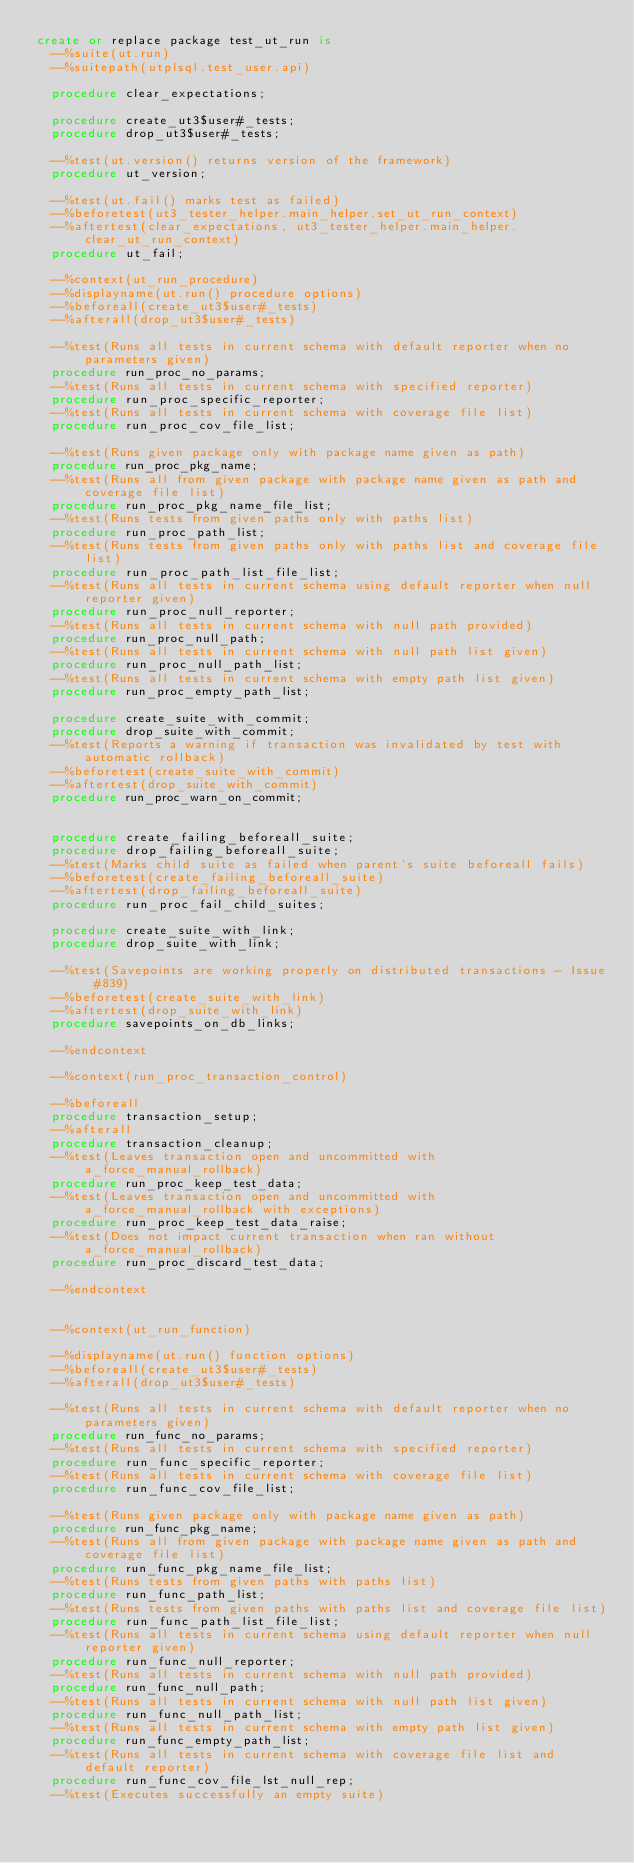Convert code to text. <code><loc_0><loc_0><loc_500><loc_500><_SQL_>create or replace package test_ut_run is
  --%suite(ut.run)
  --%suitepath(utplsql.test_user.api)

  procedure clear_expectations;
  
  procedure create_ut3$user#_tests;
  procedure drop_ut3$user#_tests;  
  
  --%test(ut.version() returns version of the framework)
  procedure ut_version;

  --%test(ut.fail() marks test as failed)
  --%beforetest(ut3_tester_helper.main_helper.set_ut_run_context)
  --%aftertest(clear_expectations, ut3_tester_helper.main_helper.clear_ut_run_context)
  procedure ut_fail;

  --%context(ut_run_procedure)
  --%displayname(ut.run() procedure options)
  --%beforeall(create_ut3$user#_tests)
  --%afterall(drop_ut3$user#_tests)

  --%test(Runs all tests in current schema with default reporter when no parameters given)
  procedure run_proc_no_params;
  --%test(Runs all tests in current schema with specified reporter)
  procedure run_proc_specific_reporter;
  --%test(Runs all tests in current schema with coverage file list)
  procedure run_proc_cov_file_list;

  --%test(Runs given package only with package name given as path)
  procedure run_proc_pkg_name;
  --%test(Runs all from given package with package name given as path and coverage file list)
  procedure run_proc_pkg_name_file_list;
  --%test(Runs tests from given paths only with paths list)
  procedure run_proc_path_list;
  --%test(Runs tests from given paths only with paths list and coverage file list)
  procedure run_proc_path_list_file_list;
  --%test(Runs all tests in current schema using default reporter when null reporter given)
  procedure run_proc_null_reporter;
  --%test(Runs all tests in current schema with null path provided)
  procedure run_proc_null_path;
  --%test(Runs all tests in current schema with null path list given)
  procedure run_proc_null_path_list;
  --%test(Runs all tests in current schema with empty path list given)
  procedure run_proc_empty_path_list;

  procedure create_suite_with_commit;
  procedure drop_suite_with_commit;
  --%test(Reports a warning if transaction was invalidated by test with automatic rollback)
  --%beforetest(create_suite_with_commit)
  --%aftertest(drop_suite_with_commit)
  procedure run_proc_warn_on_commit;


  procedure create_failing_beforeall_suite;
  procedure drop_failing_beforeall_suite;
  --%test(Marks child suite as failed when parent's suite beforeall fails)
  --%beforetest(create_failing_beforeall_suite)
  --%aftertest(drop_failing_beforeall_suite)
  procedure run_proc_fail_child_suites;

  procedure create_suite_with_link;
  procedure drop_suite_with_link;
  
  --%test(Savepoints are working properly on distributed transactions - Issue #839)
  --%beforetest(create_suite_with_link)
  --%aftertest(drop_suite_with_link)
  procedure savepoints_on_db_links;

  --%endcontext

  --%context(run_proc_transaction_control)

  --%beforeall
  procedure transaction_setup;
  --%afterall
  procedure transaction_cleanup;
  --%test(Leaves transaction open and uncommitted with a_force_manual_rollback)
  procedure run_proc_keep_test_data;
  --%test(Leaves transaction open and uncommitted with a_force_manual_rollback with exceptions)
  procedure run_proc_keep_test_data_raise;
  --%test(Does not impact current transaction when ran without a_force_manual_rollback)
  procedure run_proc_discard_test_data;

  --%endcontext


  --%context(ut_run_function)
    
  --%displayname(ut.run() function options)
  --%beforeall(create_ut3$user#_tests)
  --%afterall(drop_ut3$user#_tests)

  --%test(Runs all tests in current schema with default reporter when no parameters given)
  procedure run_func_no_params;
  --%test(Runs all tests in current schema with specified reporter)
  procedure run_func_specific_reporter;
  --%test(Runs all tests in current schema with coverage file list)
  procedure run_func_cov_file_list;

  --%test(Runs given package only with package name given as path)
  procedure run_func_pkg_name;
  --%test(Runs all from given package with package name given as path and coverage file list)
  procedure run_func_pkg_name_file_list;
  --%test(Runs tests from given paths with paths list)
  procedure run_func_path_list;
  --%test(Runs tests from given paths with paths list and coverage file list)
  procedure run_func_path_list_file_list;
  --%test(Runs all tests in current schema using default reporter when null reporter given)
  procedure run_func_null_reporter;
  --%test(Runs all tests in current schema with null path provided)
  procedure run_func_null_path;
  --%test(Runs all tests in current schema with null path list given)
  procedure run_func_null_path_list;
  --%test(Runs all tests in current schema with empty path list given)
  procedure run_func_empty_path_list;
  --%test(Runs all tests in current schema with coverage file list and default reporter)
  procedure run_func_cov_file_lst_null_rep;
  --%test(Executes successfully an empty suite)</code> 